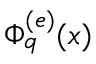Convert formula to latex. <formula><loc_0><loc_0><loc_500><loc_500>\Phi _ { q } ^ { ( e ) } ( x )</formula> 